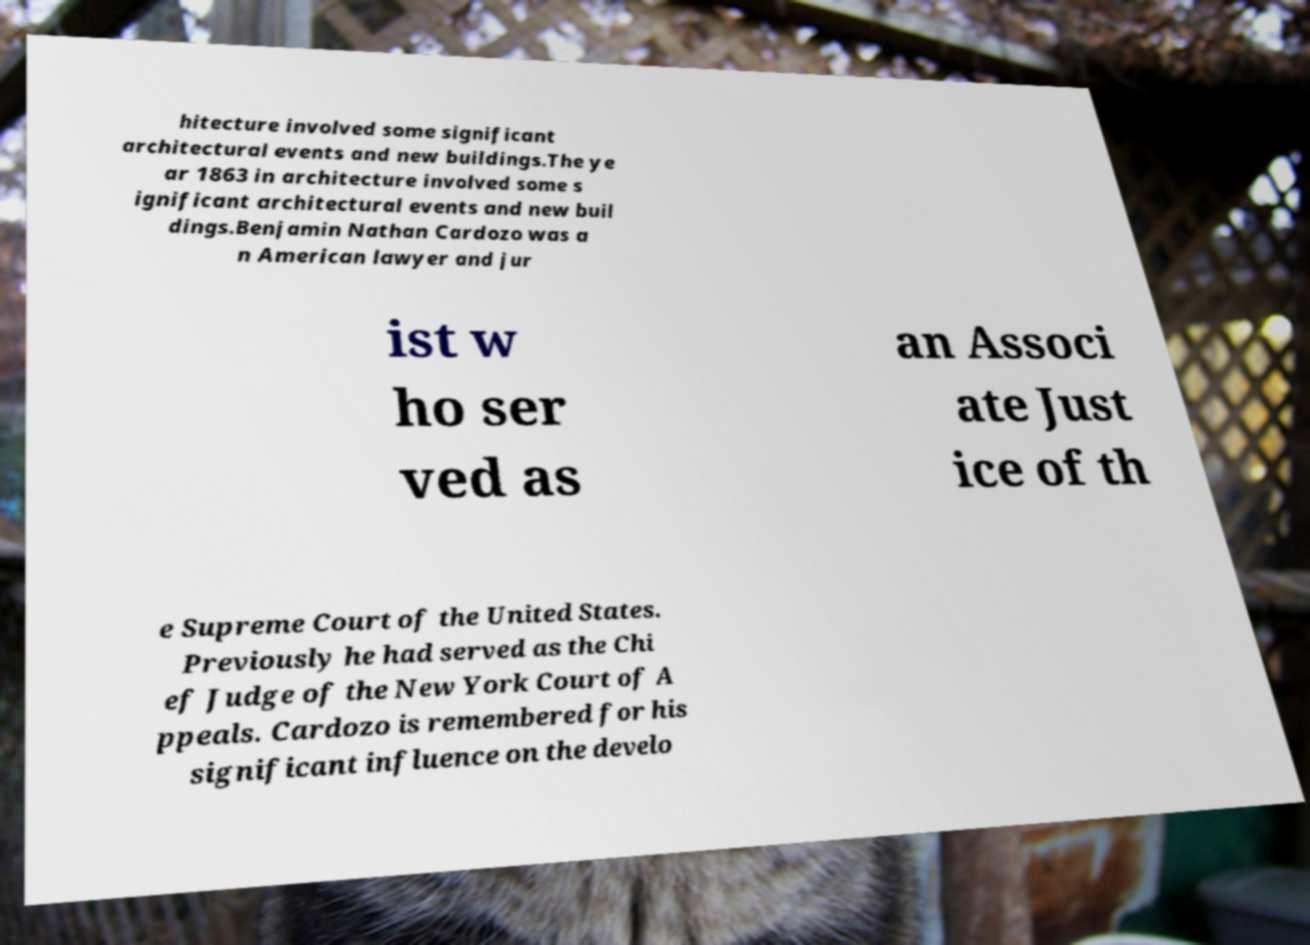Could you assist in decoding the text presented in this image and type it out clearly? hitecture involved some significant architectural events and new buildings.The ye ar 1863 in architecture involved some s ignificant architectural events and new buil dings.Benjamin Nathan Cardozo was a n American lawyer and jur ist w ho ser ved as an Associ ate Just ice of th e Supreme Court of the United States. Previously he had served as the Chi ef Judge of the New York Court of A ppeals. Cardozo is remembered for his significant influence on the develo 